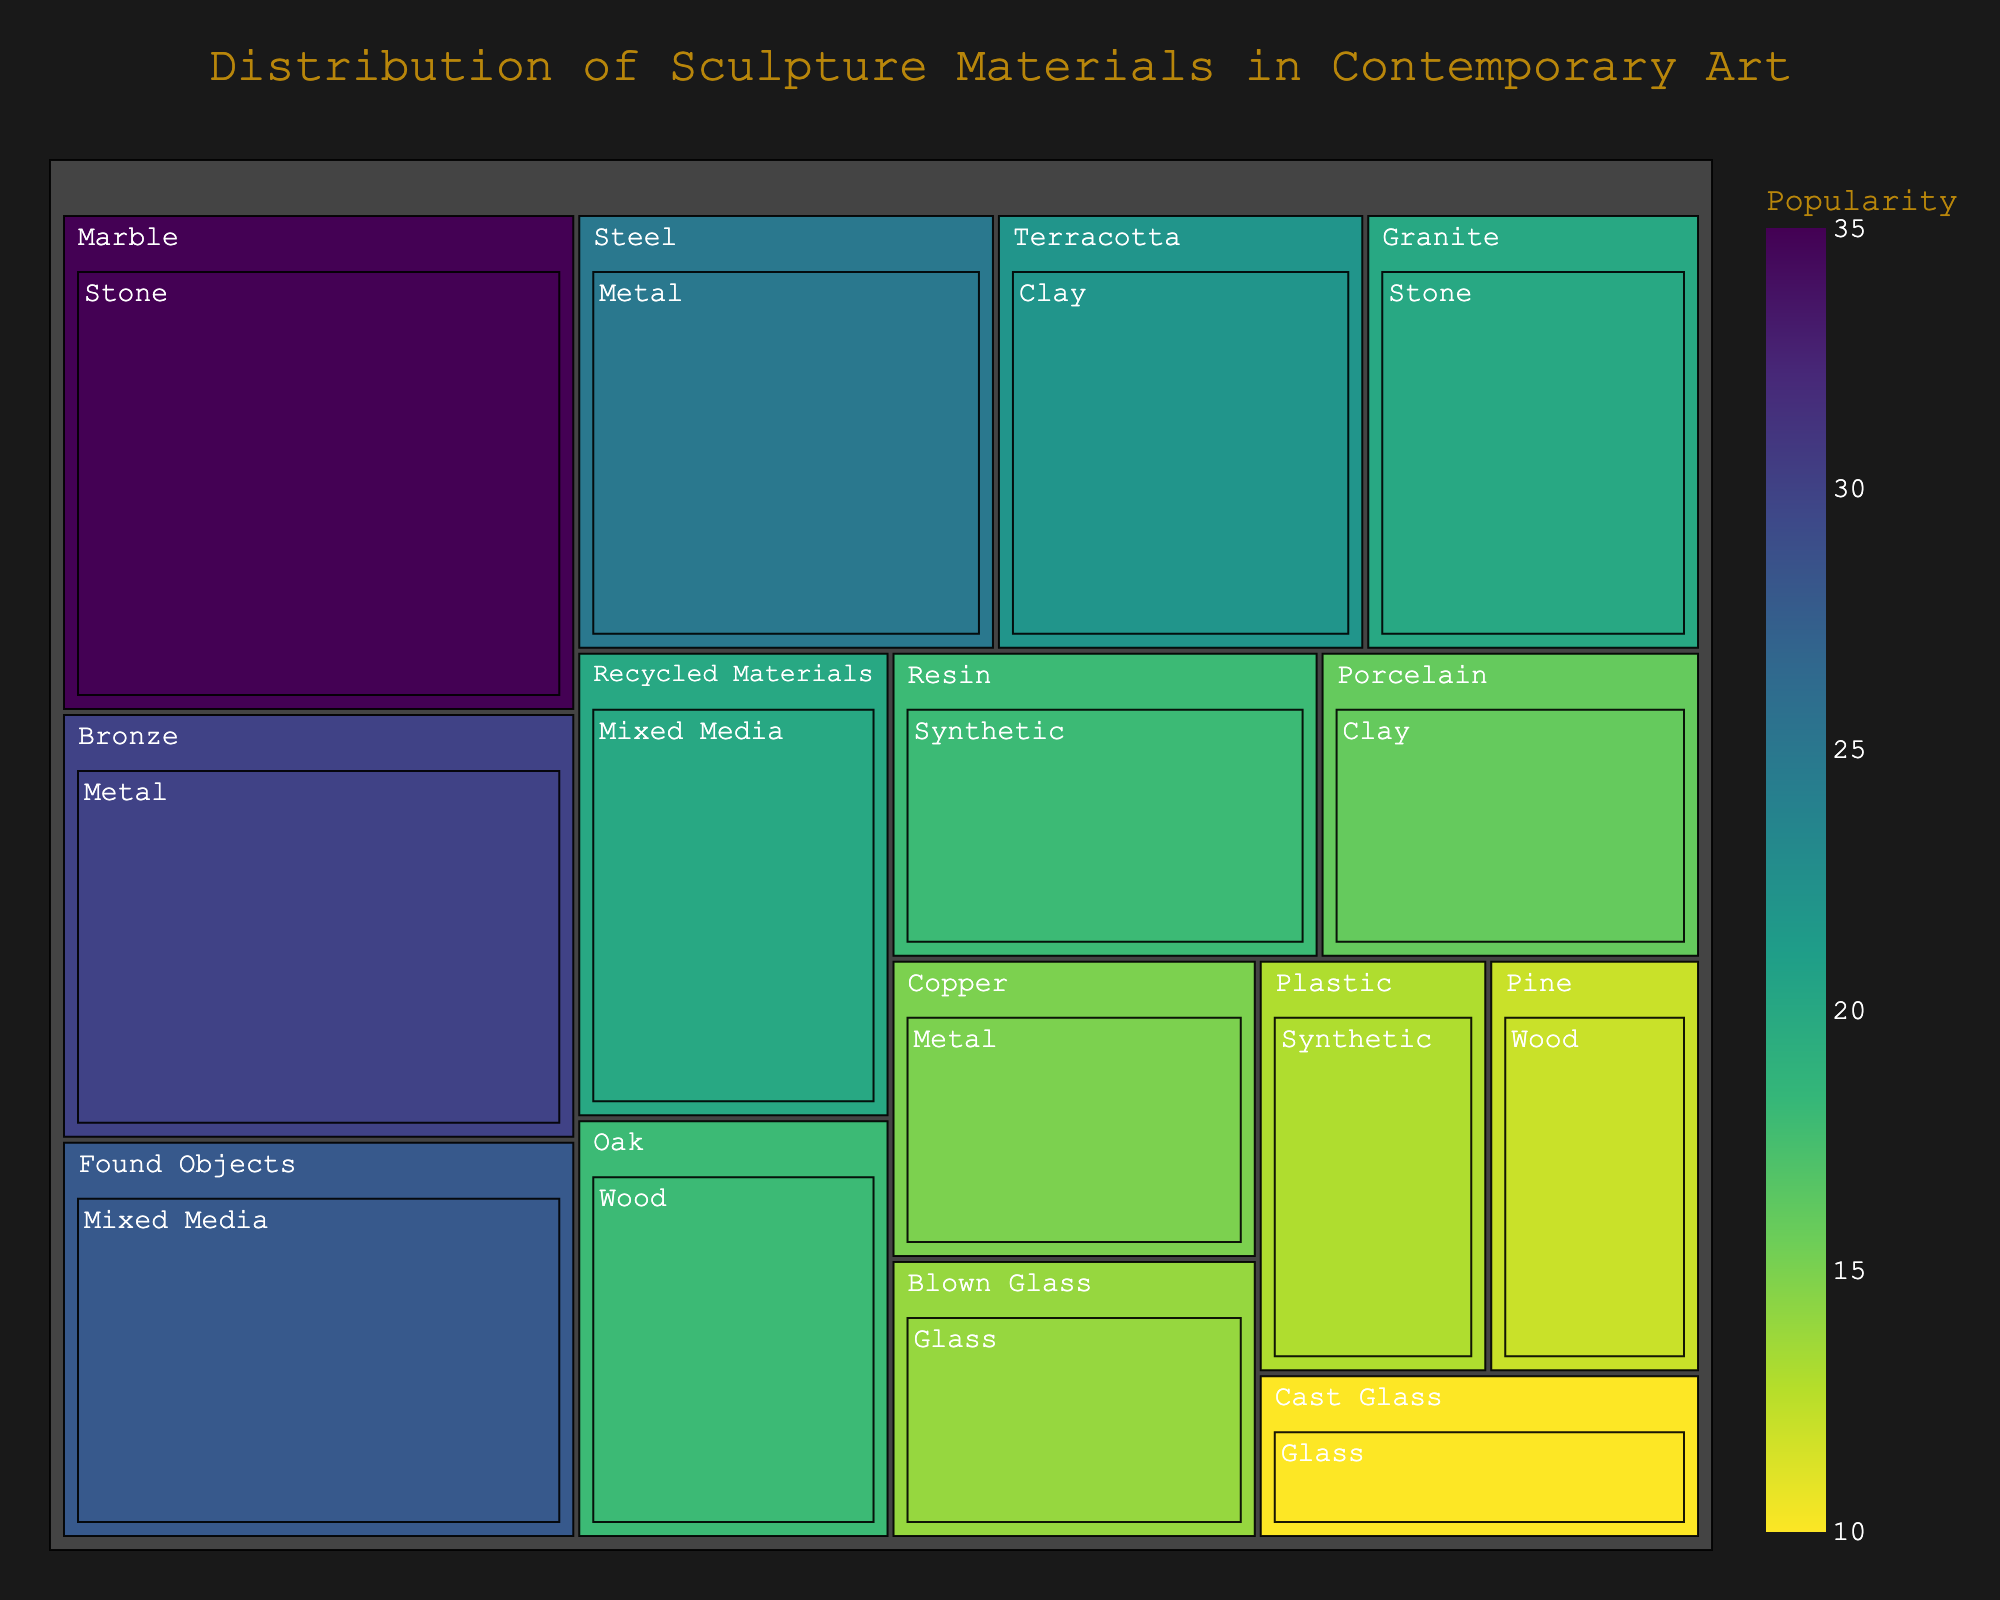Which material is the most popular in the "Stone" type? The "Stone" type includes "Marble" and "Granite." By comparing their popularity, "Marble" has a higher value (35) than "Granite" (20).
Answer: Marble Which material has the highest popularity in the "Metal" type? The "Metal" type includes "Bronze," "Steel," and "Copper." By comparing their popularity values, "Bronze" has the highest value (30).
Answer: Bronze How does the popularity of "Bronze" compare to "Marble"? "Bronze" has a popularity value of 30, whereas "Marble" has a popularity value of 35. Since 35 is greater than 30, "Marble" is more popular than "Bronze."
Answer: Marble Which type has the least popular material? By comparing the lowest popularity values across all types, "Glass" has "Cast Glass" with a popularity of 10, which is the lowest.
Answer: Glass What is the combined popularity of "Oak" and "Pine"? The popularity value for "Oak" is 18 and for "Pine" is 12. Adding these values together, the combined popularity is 18 + 12 = 30.
Answer: 30 What's the difference in popularity between "Terracotta" and "Porcelain"? "Terracotta" has a popularity of 22, and "Porcelain" has a popularity of 16. The difference is calculated as 22 - 16 = 6.
Answer: 6 Which material in the "Synthetic" type is more popular? In the "Synthetic" type, the materials are "Resin" and "Plastic." "Resin" has a popularity of 18, while "Plastic" has 13. "Resin" is more popular than "Plastic."
Answer: Resin What is the average popularity of materials in the "Wood" type? The "Wood" type includes "Oak" with a popularity of 18 and "Pine" with 12. The average is calculated as (18 + 12) / 2 = 15.
Answer: 15 How does the popularity of "Recycled Materials" compare to "Found Objects"? "Recycled Materials" has a popularity of 20, while "Found Objects" has 28. Comparing these values, "Found Objects" is more popular.
Answer: Found Objects What is the total popularity of all "Metal" materials? The "Metal" type includes "Bronze" (30), "Steel" (25), and "Copper" (15). The total is 30 + 25 + 15 = 70.
Answer: 70 